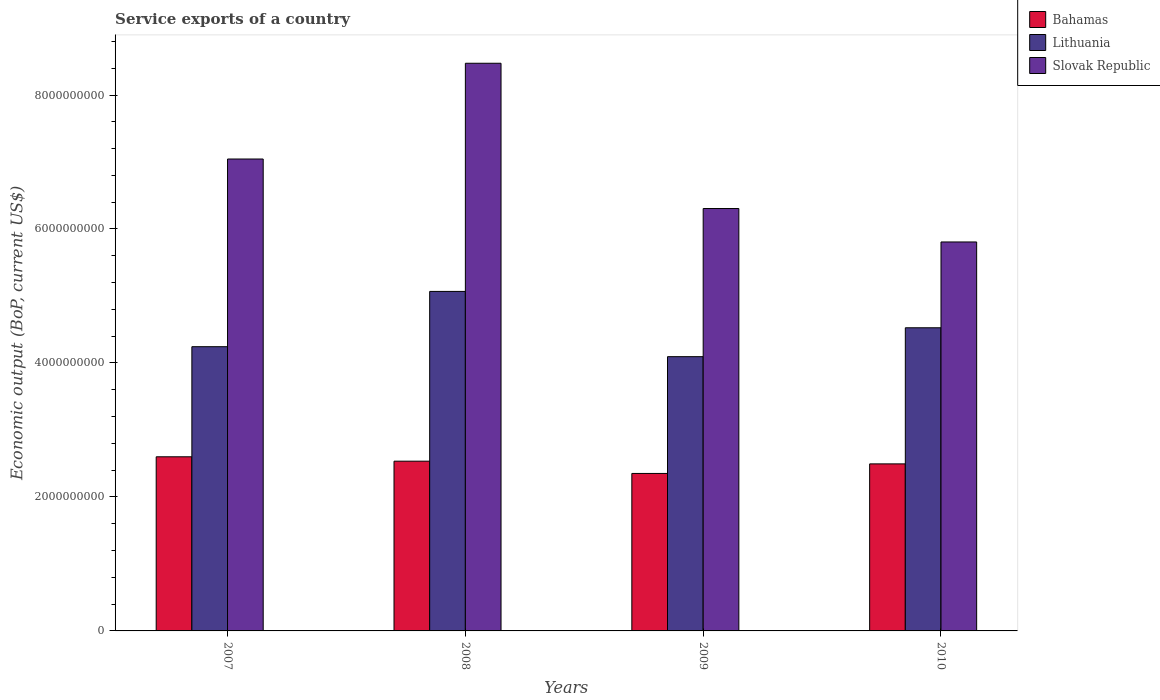How many groups of bars are there?
Ensure brevity in your answer.  4. How many bars are there on the 4th tick from the left?
Ensure brevity in your answer.  3. In how many cases, is the number of bars for a given year not equal to the number of legend labels?
Provide a succinct answer. 0. What is the service exports in Slovak Republic in 2010?
Provide a succinct answer. 5.81e+09. Across all years, what is the maximum service exports in Slovak Republic?
Provide a short and direct response. 8.47e+09. Across all years, what is the minimum service exports in Bahamas?
Offer a very short reply. 2.35e+09. What is the total service exports in Lithuania in the graph?
Keep it short and to the point. 1.79e+1. What is the difference between the service exports in Slovak Republic in 2008 and that in 2009?
Ensure brevity in your answer.  2.17e+09. What is the difference between the service exports in Bahamas in 2008 and the service exports in Slovak Republic in 2010?
Offer a terse response. -3.27e+09. What is the average service exports in Bahamas per year?
Ensure brevity in your answer.  2.49e+09. In the year 2007, what is the difference between the service exports in Bahamas and service exports in Slovak Republic?
Keep it short and to the point. -4.45e+09. What is the ratio of the service exports in Bahamas in 2008 to that in 2010?
Provide a succinct answer. 1.02. Is the service exports in Lithuania in 2009 less than that in 2010?
Keep it short and to the point. Yes. What is the difference between the highest and the second highest service exports in Slovak Republic?
Provide a short and direct response. 1.43e+09. What is the difference between the highest and the lowest service exports in Lithuania?
Your response must be concise. 9.74e+08. What does the 1st bar from the left in 2008 represents?
Provide a succinct answer. Bahamas. What does the 3rd bar from the right in 2009 represents?
Keep it short and to the point. Bahamas. What is the difference between two consecutive major ticks on the Y-axis?
Give a very brief answer. 2.00e+09. Does the graph contain grids?
Your answer should be very brief. No. Where does the legend appear in the graph?
Provide a short and direct response. Top right. How many legend labels are there?
Offer a very short reply. 3. How are the legend labels stacked?
Provide a succinct answer. Vertical. What is the title of the graph?
Your answer should be compact. Service exports of a country. What is the label or title of the X-axis?
Keep it short and to the point. Years. What is the label or title of the Y-axis?
Offer a terse response. Economic output (BoP, current US$). What is the Economic output (BoP, current US$) in Bahamas in 2007?
Ensure brevity in your answer.  2.60e+09. What is the Economic output (BoP, current US$) of Lithuania in 2007?
Make the answer very short. 4.24e+09. What is the Economic output (BoP, current US$) of Slovak Republic in 2007?
Offer a terse response. 7.04e+09. What is the Economic output (BoP, current US$) of Bahamas in 2008?
Make the answer very short. 2.53e+09. What is the Economic output (BoP, current US$) in Lithuania in 2008?
Your answer should be very brief. 5.07e+09. What is the Economic output (BoP, current US$) in Slovak Republic in 2008?
Your answer should be compact. 8.47e+09. What is the Economic output (BoP, current US$) in Bahamas in 2009?
Offer a very short reply. 2.35e+09. What is the Economic output (BoP, current US$) of Lithuania in 2009?
Offer a terse response. 4.09e+09. What is the Economic output (BoP, current US$) in Slovak Republic in 2009?
Provide a short and direct response. 6.31e+09. What is the Economic output (BoP, current US$) in Bahamas in 2010?
Offer a very short reply. 2.49e+09. What is the Economic output (BoP, current US$) of Lithuania in 2010?
Give a very brief answer. 4.53e+09. What is the Economic output (BoP, current US$) of Slovak Republic in 2010?
Ensure brevity in your answer.  5.81e+09. Across all years, what is the maximum Economic output (BoP, current US$) of Bahamas?
Make the answer very short. 2.60e+09. Across all years, what is the maximum Economic output (BoP, current US$) of Lithuania?
Offer a terse response. 5.07e+09. Across all years, what is the maximum Economic output (BoP, current US$) in Slovak Republic?
Offer a terse response. 8.47e+09. Across all years, what is the minimum Economic output (BoP, current US$) of Bahamas?
Your answer should be very brief. 2.35e+09. Across all years, what is the minimum Economic output (BoP, current US$) of Lithuania?
Keep it short and to the point. 4.09e+09. Across all years, what is the minimum Economic output (BoP, current US$) in Slovak Republic?
Your answer should be very brief. 5.81e+09. What is the total Economic output (BoP, current US$) in Bahamas in the graph?
Offer a terse response. 9.98e+09. What is the total Economic output (BoP, current US$) of Lithuania in the graph?
Offer a very short reply. 1.79e+1. What is the total Economic output (BoP, current US$) in Slovak Republic in the graph?
Keep it short and to the point. 2.76e+1. What is the difference between the Economic output (BoP, current US$) of Bahamas in 2007 and that in 2008?
Give a very brief answer. 6.54e+07. What is the difference between the Economic output (BoP, current US$) in Lithuania in 2007 and that in 2008?
Offer a very short reply. -8.25e+08. What is the difference between the Economic output (BoP, current US$) in Slovak Republic in 2007 and that in 2008?
Your answer should be very brief. -1.43e+09. What is the difference between the Economic output (BoP, current US$) of Bahamas in 2007 and that in 2009?
Keep it short and to the point. 2.48e+08. What is the difference between the Economic output (BoP, current US$) of Lithuania in 2007 and that in 2009?
Your response must be concise. 1.49e+08. What is the difference between the Economic output (BoP, current US$) in Slovak Republic in 2007 and that in 2009?
Your answer should be very brief. 7.39e+08. What is the difference between the Economic output (BoP, current US$) of Bahamas in 2007 and that in 2010?
Ensure brevity in your answer.  1.06e+08. What is the difference between the Economic output (BoP, current US$) in Lithuania in 2007 and that in 2010?
Ensure brevity in your answer.  -2.82e+08. What is the difference between the Economic output (BoP, current US$) in Slovak Republic in 2007 and that in 2010?
Give a very brief answer. 1.24e+09. What is the difference between the Economic output (BoP, current US$) in Bahamas in 2008 and that in 2009?
Your answer should be very brief. 1.83e+08. What is the difference between the Economic output (BoP, current US$) of Lithuania in 2008 and that in 2009?
Ensure brevity in your answer.  9.74e+08. What is the difference between the Economic output (BoP, current US$) of Slovak Republic in 2008 and that in 2009?
Your answer should be very brief. 2.17e+09. What is the difference between the Economic output (BoP, current US$) in Bahamas in 2008 and that in 2010?
Your response must be concise. 4.04e+07. What is the difference between the Economic output (BoP, current US$) of Lithuania in 2008 and that in 2010?
Your response must be concise. 5.43e+08. What is the difference between the Economic output (BoP, current US$) in Slovak Republic in 2008 and that in 2010?
Your answer should be compact. 2.67e+09. What is the difference between the Economic output (BoP, current US$) of Bahamas in 2009 and that in 2010?
Ensure brevity in your answer.  -1.43e+08. What is the difference between the Economic output (BoP, current US$) of Lithuania in 2009 and that in 2010?
Your answer should be very brief. -4.31e+08. What is the difference between the Economic output (BoP, current US$) of Slovak Republic in 2009 and that in 2010?
Your answer should be compact. 4.99e+08. What is the difference between the Economic output (BoP, current US$) of Bahamas in 2007 and the Economic output (BoP, current US$) of Lithuania in 2008?
Offer a terse response. -2.47e+09. What is the difference between the Economic output (BoP, current US$) in Bahamas in 2007 and the Economic output (BoP, current US$) in Slovak Republic in 2008?
Ensure brevity in your answer.  -5.87e+09. What is the difference between the Economic output (BoP, current US$) in Lithuania in 2007 and the Economic output (BoP, current US$) in Slovak Republic in 2008?
Your answer should be compact. -4.23e+09. What is the difference between the Economic output (BoP, current US$) of Bahamas in 2007 and the Economic output (BoP, current US$) of Lithuania in 2009?
Your answer should be very brief. -1.49e+09. What is the difference between the Economic output (BoP, current US$) of Bahamas in 2007 and the Economic output (BoP, current US$) of Slovak Republic in 2009?
Keep it short and to the point. -3.71e+09. What is the difference between the Economic output (BoP, current US$) in Lithuania in 2007 and the Economic output (BoP, current US$) in Slovak Republic in 2009?
Your response must be concise. -2.06e+09. What is the difference between the Economic output (BoP, current US$) in Bahamas in 2007 and the Economic output (BoP, current US$) in Lithuania in 2010?
Ensure brevity in your answer.  -1.93e+09. What is the difference between the Economic output (BoP, current US$) of Bahamas in 2007 and the Economic output (BoP, current US$) of Slovak Republic in 2010?
Give a very brief answer. -3.21e+09. What is the difference between the Economic output (BoP, current US$) in Lithuania in 2007 and the Economic output (BoP, current US$) in Slovak Republic in 2010?
Give a very brief answer. -1.56e+09. What is the difference between the Economic output (BoP, current US$) in Bahamas in 2008 and the Economic output (BoP, current US$) in Lithuania in 2009?
Make the answer very short. -1.56e+09. What is the difference between the Economic output (BoP, current US$) in Bahamas in 2008 and the Economic output (BoP, current US$) in Slovak Republic in 2009?
Ensure brevity in your answer.  -3.77e+09. What is the difference between the Economic output (BoP, current US$) of Lithuania in 2008 and the Economic output (BoP, current US$) of Slovak Republic in 2009?
Your answer should be compact. -1.24e+09. What is the difference between the Economic output (BoP, current US$) in Bahamas in 2008 and the Economic output (BoP, current US$) in Lithuania in 2010?
Provide a short and direct response. -1.99e+09. What is the difference between the Economic output (BoP, current US$) in Bahamas in 2008 and the Economic output (BoP, current US$) in Slovak Republic in 2010?
Your answer should be very brief. -3.27e+09. What is the difference between the Economic output (BoP, current US$) of Lithuania in 2008 and the Economic output (BoP, current US$) of Slovak Republic in 2010?
Make the answer very short. -7.38e+08. What is the difference between the Economic output (BoP, current US$) of Bahamas in 2009 and the Economic output (BoP, current US$) of Lithuania in 2010?
Your response must be concise. -2.17e+09. What is the difference between the Economic output (BoP, current US$) of Bahamas in 2009 and the Economic output (BoP, current US$) of Slovak Republic in 2010?
Your response must be concise. -3.46e+09. What is the difference between the Economic output (BoP, current US$) in Lithuania in 2009 and the Economic output (BoP, current US$) in Slovak Republic in 2010?
Offer a very short reply. -1.71e+09. What is the average Economic output (BoP, current US$) in Bahamas per year?
Your answer should be very brief. 2.49e+09. What is the average Economic output (BoP, current US$) of Lithuania per year?
Make the answer very short. 4.48e+09. What is the average Economic output (BoP, current US$) in Slovak Republic per year?
Ensure brevity in your answer.  6.91e+09. In the year 2007, what is the difference between the Economic output (BoP, current US$) of Bahamas and Economic output (BoP, current US$) of Lithuania?
Your response must be concise. -1.64e+09. In the year 2007, what is the difference between the Economic output (BoP, current US$) in Bahamas and Economic output (BoP, current US$) in Slovak Republic?
Give a very brief answer. -4.45e+09. In the year 2007, what is the difference between the Economic output (BoP, current US$) of Lithuania and Economic output (BoP, current US$) of Slovak Republic?
Make the answer very short. -2.80e+09. In the year 2008, what is the difference between the Economic output (BoP, current US$) of Bahamas and Economic output (BoP, current US$) of Lithuania?
Ensure brevity in your answer.  -2.53e+09. In the year 2008, what is the difference between the Economic output (BoP, current US$) of Bahamas and Economic output (BoP, current US$) of Slovak Republic?
Your answer should be compact. -5.94e+09. In the year 2008, what is the difference between the Economic output (BoP, current US$) of Lithuania and Economic output (BoP, current US$) of Slovak Republic?
Keep it short and to the point. -3.41e+09. In the year 2009, what is the difference between the Economic output (BoP, current US$) in Bahamas and Economic output (BoP, current US$) in Lithuania?
Your answer should be very brief. -1.74e+09. In the year 2009, what is the difference between the Economic output (BoP, current US$) of Bahamas and Economic output (BoP, current US$) of Slovak Republic?
Ensure brevity in your answer.  -3.95e+09. In the year 2009, what is the difference between the Economic output (BoP, current US$) of Lithuania and Economic output (BoP, current US$) of Slovak Republic?
Provide a short and direct response. -2.21e+09. In the year 2010, what is the difference between the Economic output (BoP, current US$) of Bahamas and Economic output (BoP, current US$) of Lithuania?
Make the answer very short. -2.03e+09. In the year 2010, what is the difference between the Economic output (BoP, current US$) in Bahamas and Economic output (BoP, current US$) in Slovak Republic?
Provide a short and direct response. -3.31e+09. In the year 2010, what is the difference between the Economic output (BoP, current US$) of Lithuania and Economic output (BoP, current US$) of Slovak Republic?
Your answer should be compact. -1.28e+09. What is the ratio of the Economic output (BoP, current US$) of Bahamas in 2007 to that in 2008?
Your response must be concise. 1.03. What is the ratio of the Economic output (BoP, current US$) in Lithuania in 2007 to that in 2008?
Provide a short and direct response. 0.84. What is the ratio of the Economic output (BoP, current US$) of Slovak Republic in 2007 to that in 2008?
Keep it short and to the point. 0.83. What is the ratio of the Economic output (BoP, current US$) in Bahamas in 2007 to that in 2009?
Make the answer very short. 1.11. What is the ratio of the Economic output (BoP, current US$) in Lithuania in 2007 to that in 2009?
Offer a terse response. 1.04. What is the ratio of the Economic output (BoP, current US$) of Slovak Republic in 2007 to that in 2009?
Offer a very short reply. 1.12. What is the ratio of the Economic output (BoP, current US$) of Bahamas in 2007 to that in 2010?
Keep it short and to the point. 1.04. What is the ratio of the Economic output (BoP, current US$) in Lithuania in 2007 to that in 2010?
Your answer should be compact. 0.94. What is the ratio of the Economic output (BoP, current US$) in Slovak Republic in 2007 to that in 2010?
Provide a short and direct response. 1.21. What is the ratio of the Economic output (BoP, current US$) of Bahamas in 2008 to that in 2009?
Your answer should be very brief. 1.08. What is the ratio of the Economic output (BoP, current US$) in Lithuania in 2008 to that in 2009?
Your response must be concise. 1.24. What is the ratio of the Economic output (BoP, current US$) in Slovak Republic in 2008 to that in 2009?
Your answer should be compact. 1.34. What is the ratio of the Economic output (BoP, current US$) in Bahamas in 2008 to that in 2010?
Make the answer very short. 1.02. What is the ratio of the Economic output (BoP, current US$) in Lithuania in 2008 to that in 2010?
Your answer should be very brief. 1.12. What is the ratio of the Economic output (BoP, current US$) in Slovak Republic in 2008 to that in 2010?
Keep it short and to the point. 1.46. What is the ratio of the Economic output (BoP, current US$) of Bahamas in 2009 to that in 2010?
Keep it short and to the point. 0.94. What is the ratio of the Economic output (BoP, current US$) in Lithuania in 2009 to that in 2010?
Your answer should be compact. 0.9. What is the ratio of the Economic output (BoP, current US$) in Slovak Republic in 2009 to that in 2010?
Your answer should be very brief. 1.09. What is the difference between the highest and the second highest Economic output (BoP, current US$) in Bahamas?
Keep it short and to the point. 6.54e+07. What is the difference between the highest and the second highest Economic output (BoP, current US$) of Lithuania?
Your answer should be very brief. 5.43e+08. What is the difference between the highest and the second highest Economic output (BoP, current US$) in Slovak Republic?
Offer a terse response. 1.43e+09. What is the difference between the highest and the lowest Economic output (BoP, current US$) of Bahamas?
Your answer should be compact. 2.48e+08. What is the difference between the highest and the lowest Economic output (BoP, current US$) in Lithuania?
Make the answer very short. 9.74e+08. What is the difference between the highest and the lowest Economic output (BoP, current US$) of Slovak Republic?
Offer a terse response. 2.67e+09. 